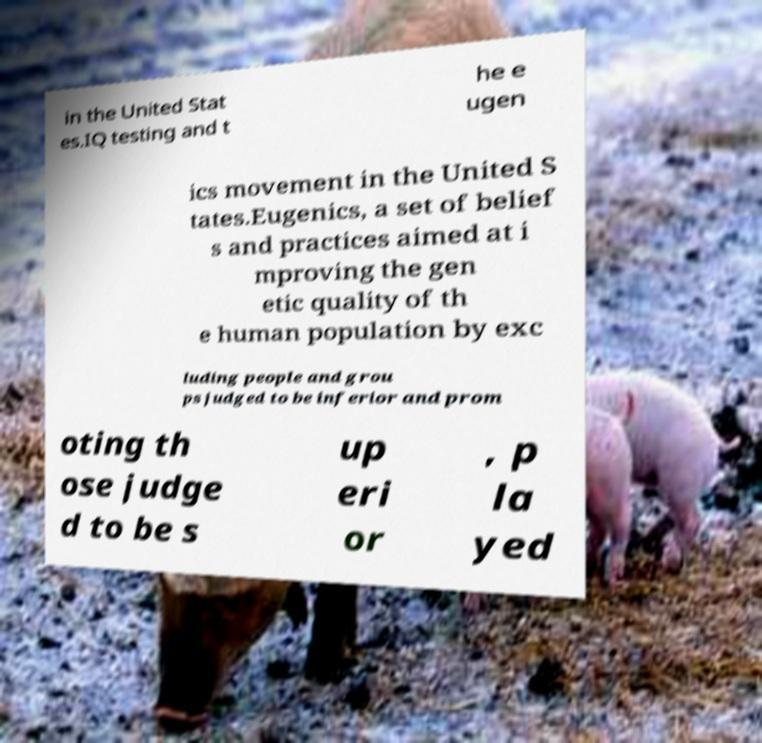Can you accurately transcribe the text from the provided image for me? in the United Stat es.IQ testing and t he e ugen ics movement in the United S tates.Eugenics, a set of belief s and practices aimed at i mproving the gen etic quality of th e human population by exc luding people and grou ps judged to be inferior and prom oting th ose judge d to be s up eri or , p la yed 